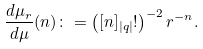Convert formula to latex. <formula><loc_0><loc_0><loc_500><loc_500>\frac { d \mu _ { r } } { d \mu } ( n ) \colon = \left ( [ n ] _ { | q | } ! \right ) ^ { - 2 } r ^ { - n } .</formula> 